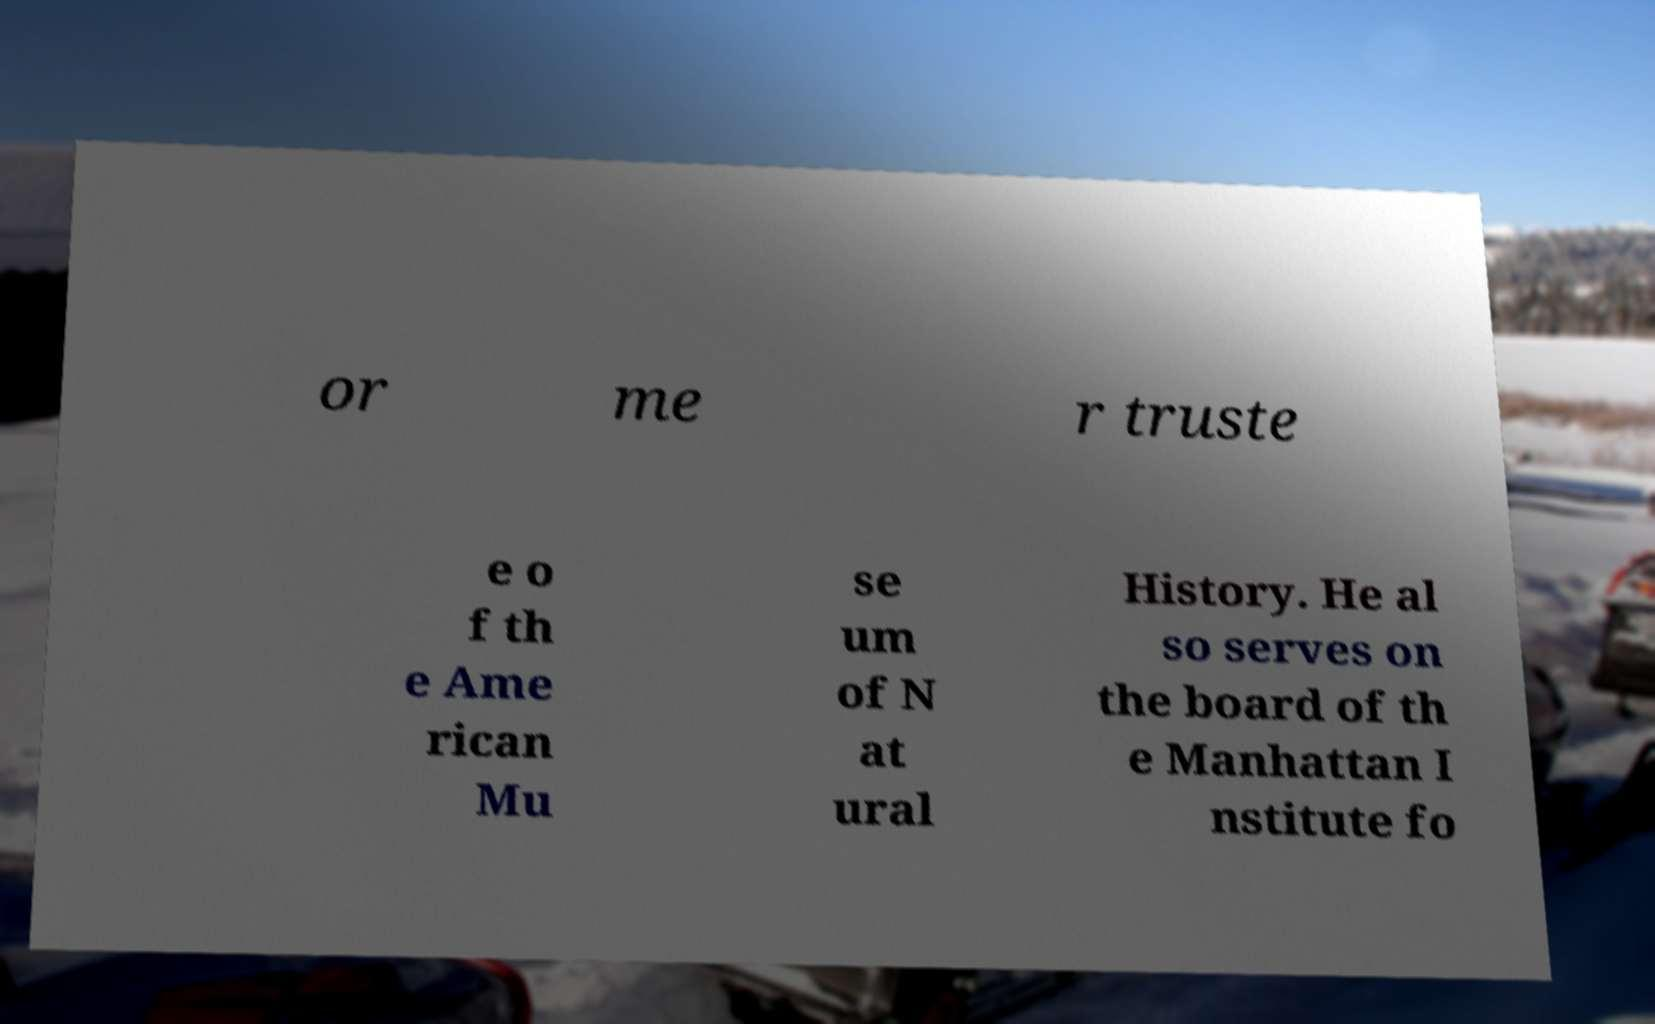Please identify and transcribe the text found in this image. or me r truste e o f th e Ame rican Mu se um of N at ural History. He al so serves on the board of th e Manhattan I nstitute fo 